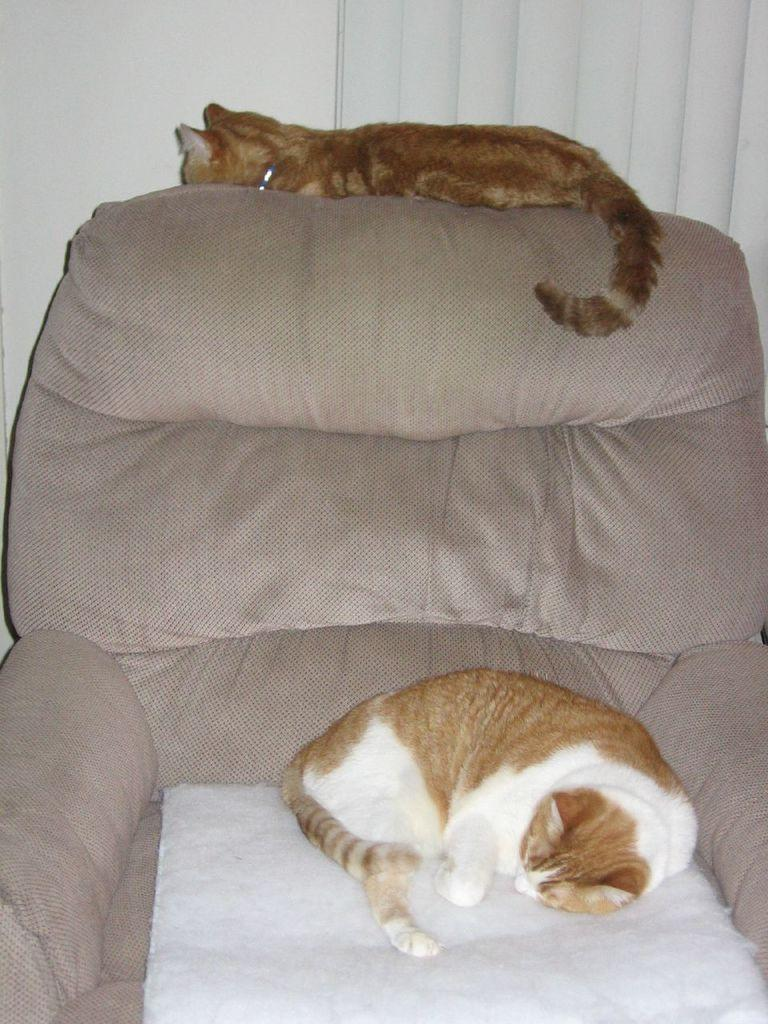How many cats are present in the image? There are two cats in the image. What are the cats doing in the image? The cats are laying on a couch. What can be seen in the background of the image? There is a curtain in the background of the image. What is behind the curtain in the image? There is a wall behind the curtain in the image. What type of cart is being pulled by the cats in the image? There is no cart present in the image, and the cats are not pulling anything. 